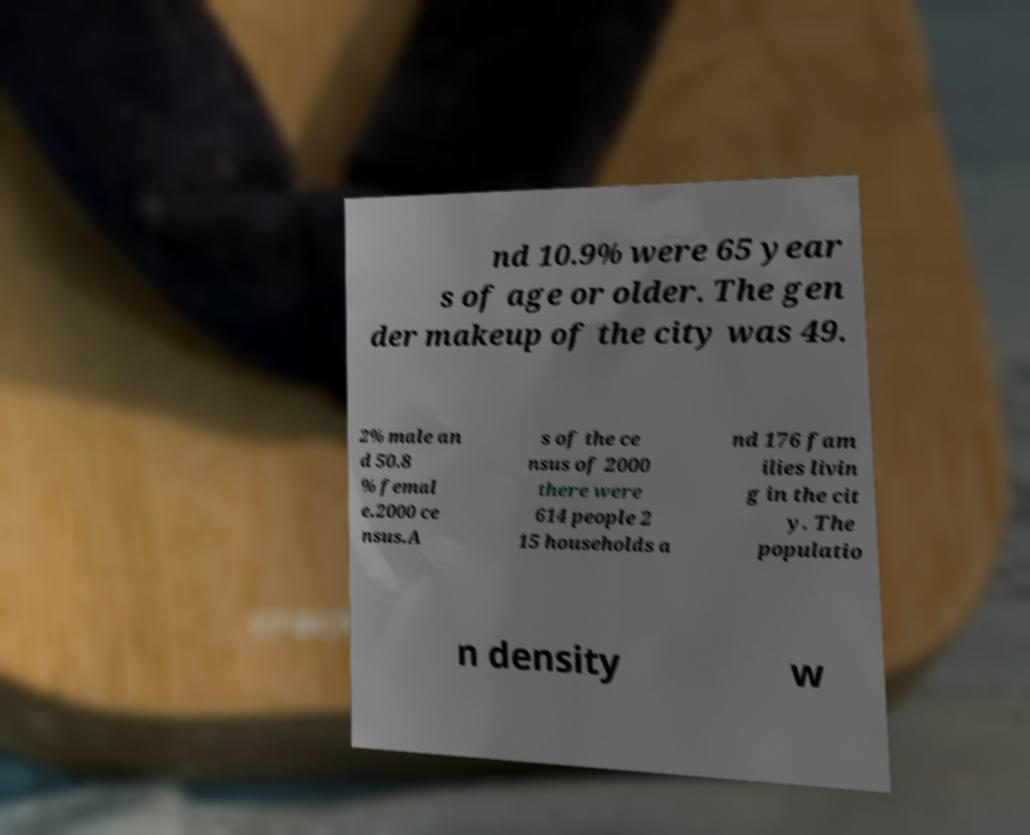Can you read and provide the text displayed in the image?This photo seems to have some interesting text. Can you extract and type it out for me? nd 10.9% were 65 year s of age or older. The gen der makeup of the city was 49. 2% male an d 50.8 % femal e.2000 ce nsus.A s of the ce nsus of 2000 there were 614 people 2 15 households a nd 176 fam ilies livin g in the cit y. The populatio n density w 